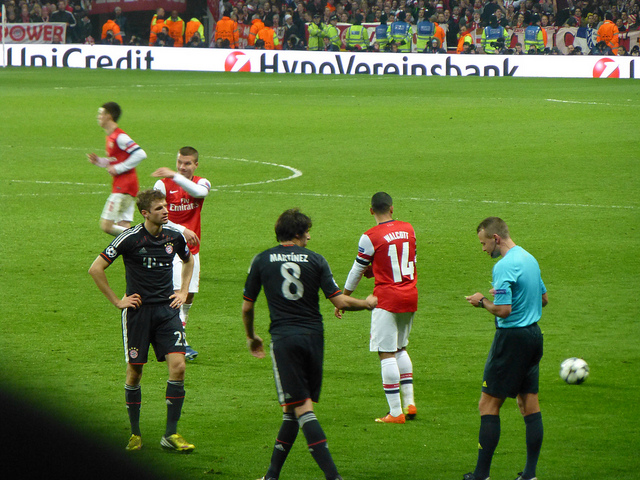Identify and read out the text in this image. POWER UniCredit HYPOVEREINSBANK Emirat MARTINEZ 25 8 14 